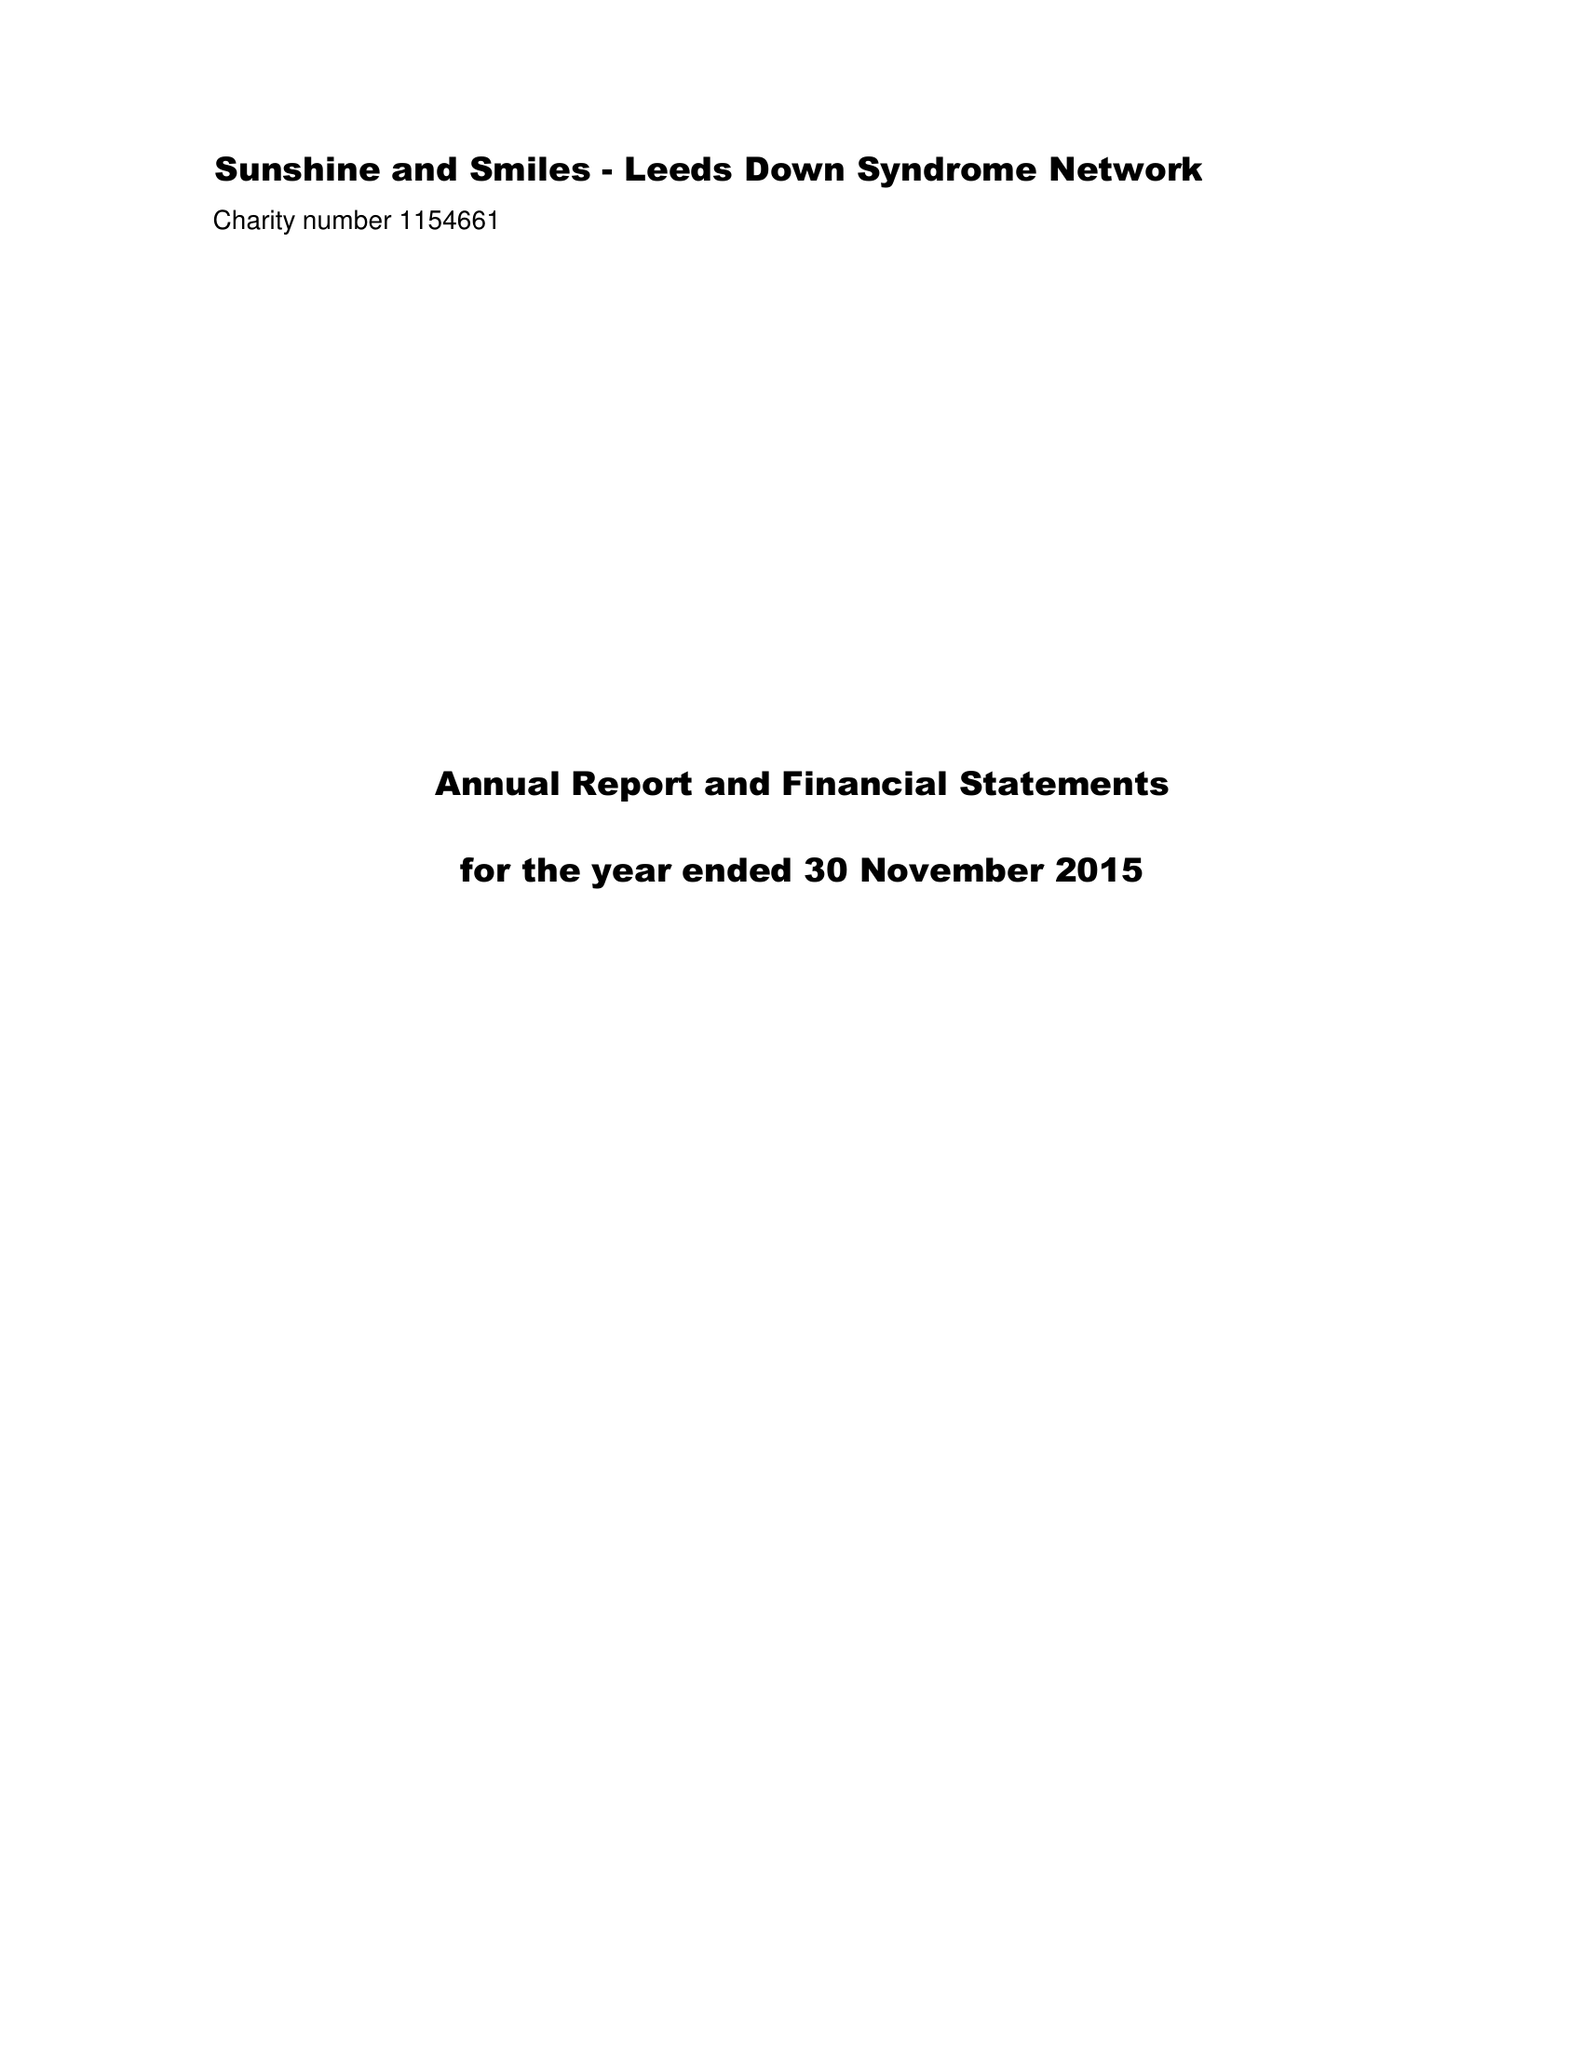What is the value for the income_annually_in_british_pounds?
Answer the question using a single word or phrase. 102018.00 